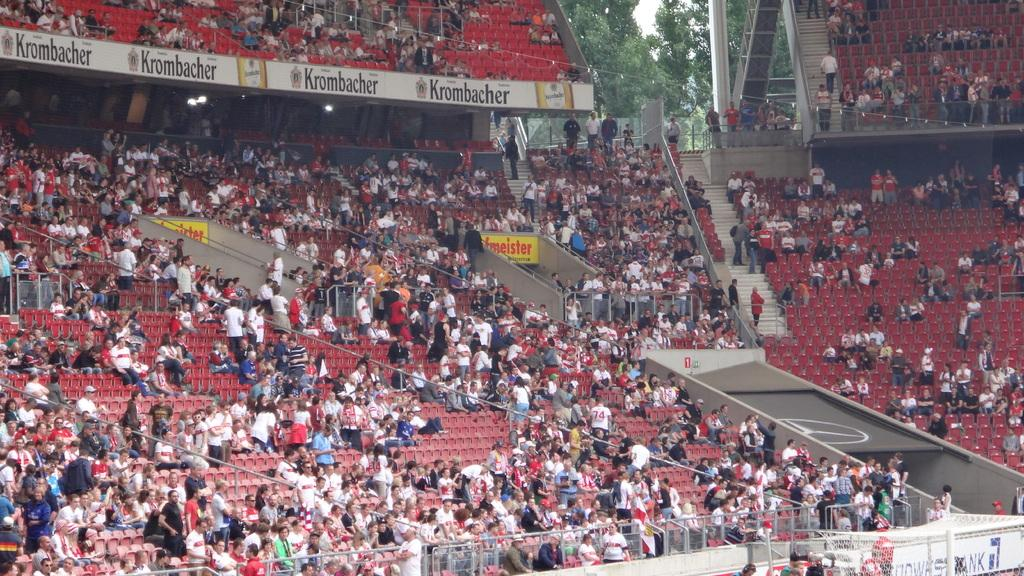How many people are in the image? There is a group of people in the image, but the exact number is not specified. What are some of the people in the image doing? Some people are sitting on chairs, while others are standing. What architectural feature can be seen in the image? There are steps in the image. What type of illumination is present in the image? There are lights in the image. What type of barrier is visible in the image? There is a fence in the image. What can be seen in the background of the image? There are trees in the background of the image. What type of owl can be seen perched on the fence in the image? There is no owl present in the image; it only features a group of people, steps, lights, a fence, and trees in the background. Is there a ghost visible in the image? There is no ghost present in the image. 